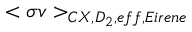<formula> <loc_0><loc_0><loc_500><loc_500>< \sigma v > _ { C X , D _ { 2 } , e f f , E i r e n e }</formula> 